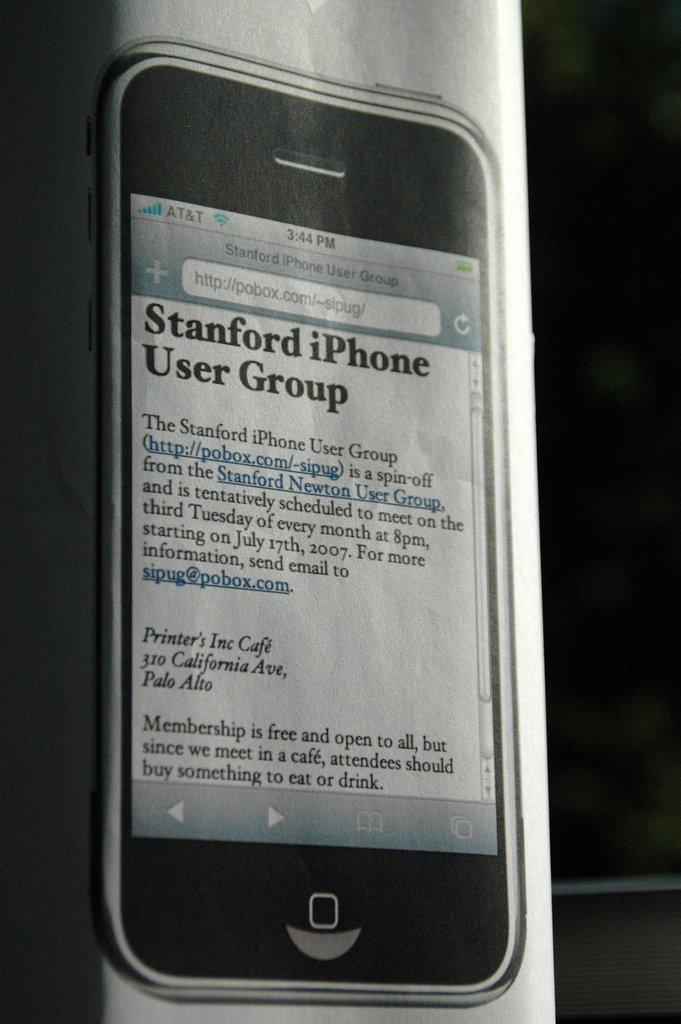<image>
Give a short and clear explanation of the subsequent image. A picture of an iPhone shows pobox.com open on its display. 